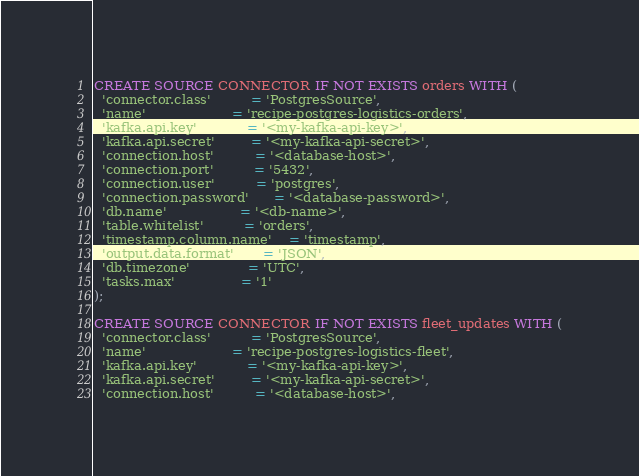<code> <loc_0><loc_0><loc_500><loc_500><_SQL_>CREATE SOURCE CONNECTOR IF NOT EXISTS orders WITH (
  'connector.class'          = 'PostgresSource',
  'name'                     = 'recipe-postgres-logistics-orders',
  'kafka.api.key'            = '<my-kafka-api-key>',
  'kafka.api.secret'         = '<my-kafka-api-secret>',
  'connection.host'          = '<database-host>',
  'connection.port'          = '5432',
  'connection.user'          = 'postgres',
  'connection.password'      = '<database-password>',
  'db.name'                  = '<db-name>',
  'table.whitelist'          = 'orders',
  'timestamp.column.name'    = 'timestamp',
  'output.data.format'       = 'JSON',
  'db.timezone'              = 'UTC',
  'tasks.max'                = '1'
);

CREATE SOURCE CONNECTOR IF NOT EXISTS fleet_updates WITH (
  'connector.class'          = 'PostgresSource',
  'name'                     = 'recipe-postgres-logistics-fleet',
  'kafka.api.key'            = '<my-kafka-api-key>',
  'kafka.api.secret'         = '<my-kafka-api-secret>',
  'connection.host'          = '<database-host>',</code> 